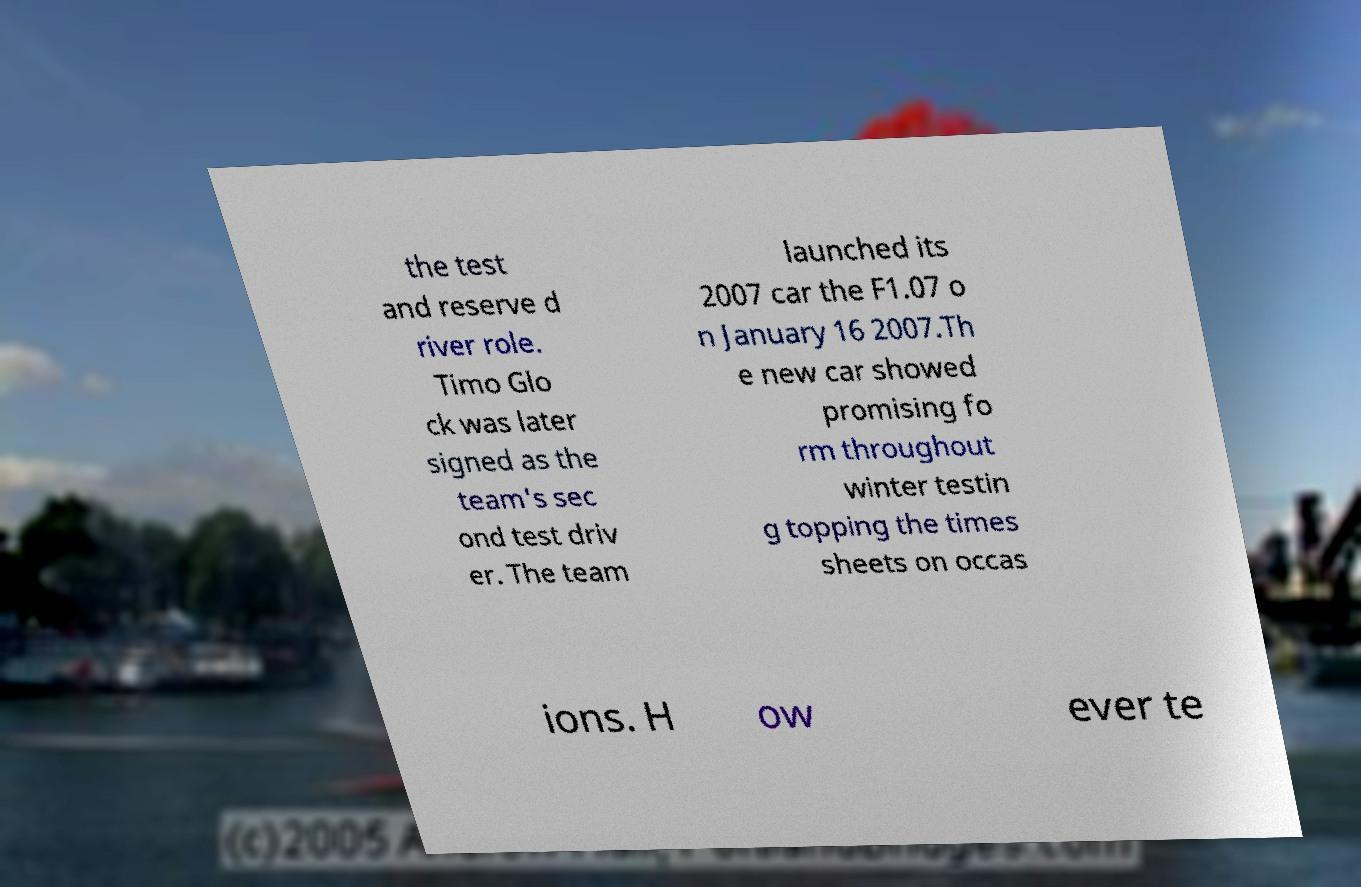Can you read and provide the text displayed in the image?This photo seems to have some interesting text. Can you extract and type it out for me? the test and reserve d river role. Timo Glo ck was later signed as the team's sec ond test driv er. The team launched its 2007 car the F1.07 o n January 16 2007.Th e new car showed promising fo rm throughout winter testin g topping the times sheets on occas ions. H ow ever te 